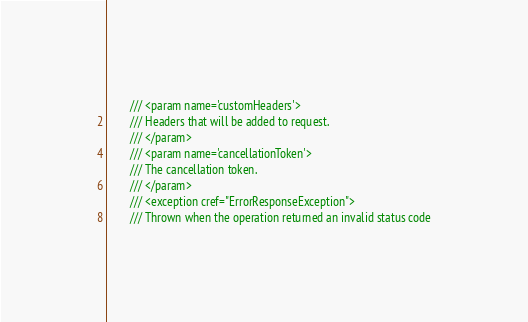Convert code to text. <code><loc_0><loc_0><loc_500><loc_500><_C#_>        /// <param name='customHeaders'>
        /// Headers that will be added to request.
        /// </param>
        /// <param name='cancellationToken'>
        /// The cancellation token.
        /// </param>
        /// <exception cref="ErrorResponseException">
        /// Thrown when the operation returned an invalid status code</code> 